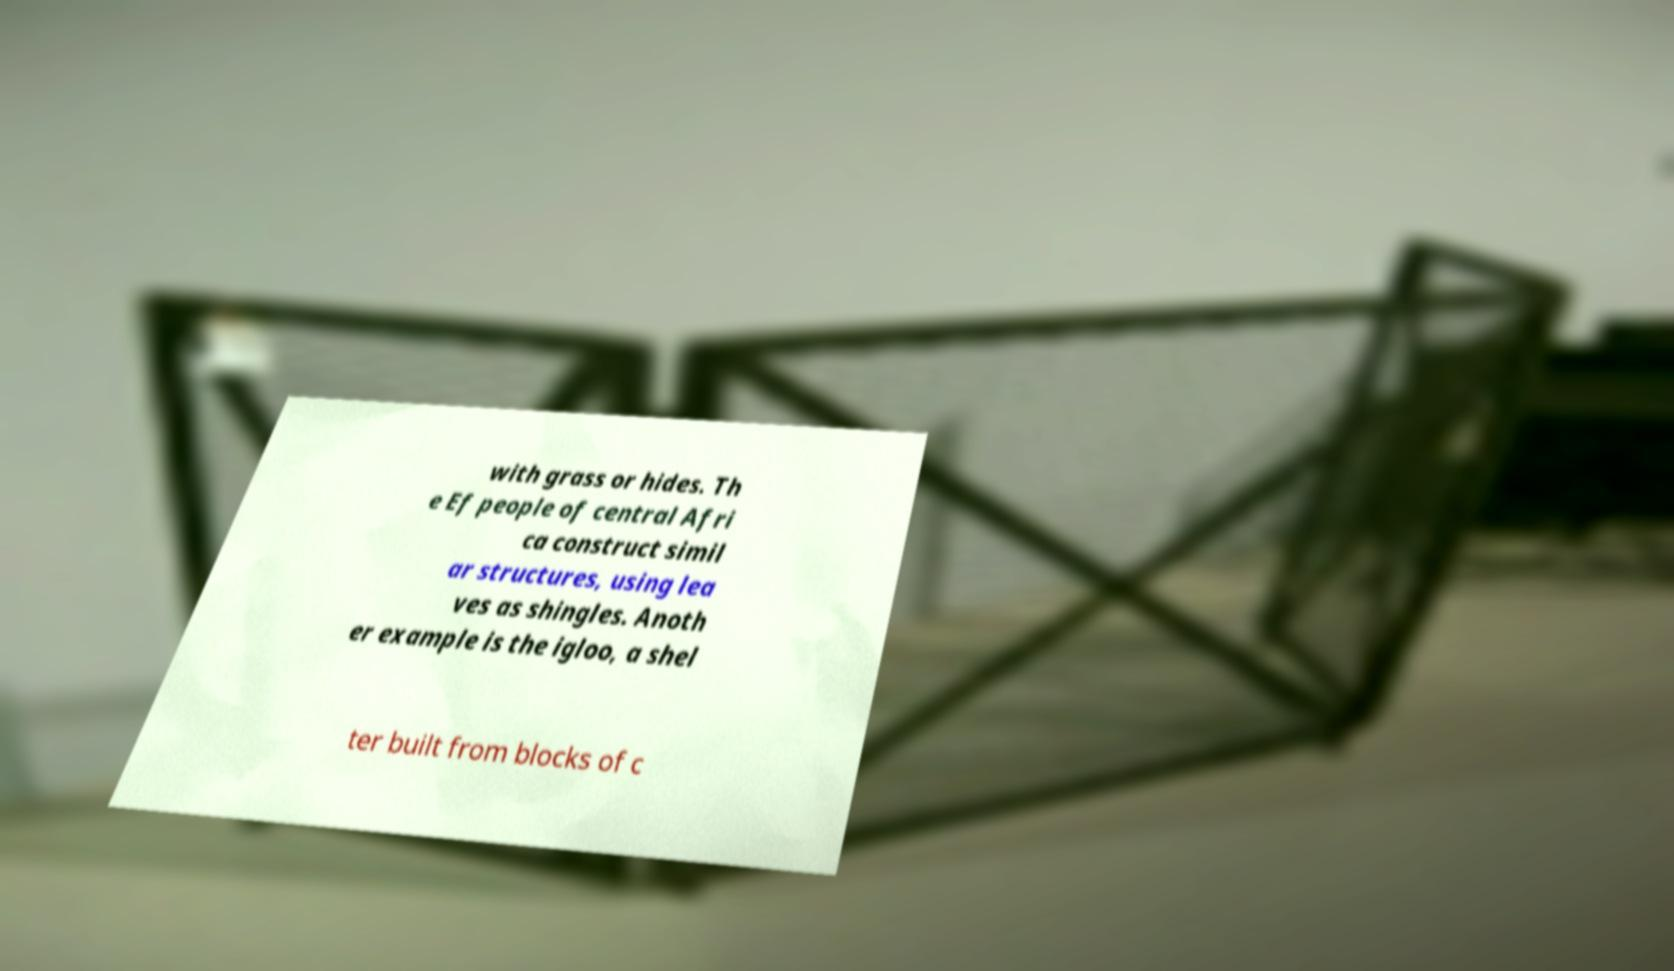Can you accurately transcribe the text from the provided image for me? with grass or hides. Th e Ef people of central Afri ca construct simil ar structures, using lea ves as shingles. Anoth er example is the igloo, a shel ter built from blocks of c 